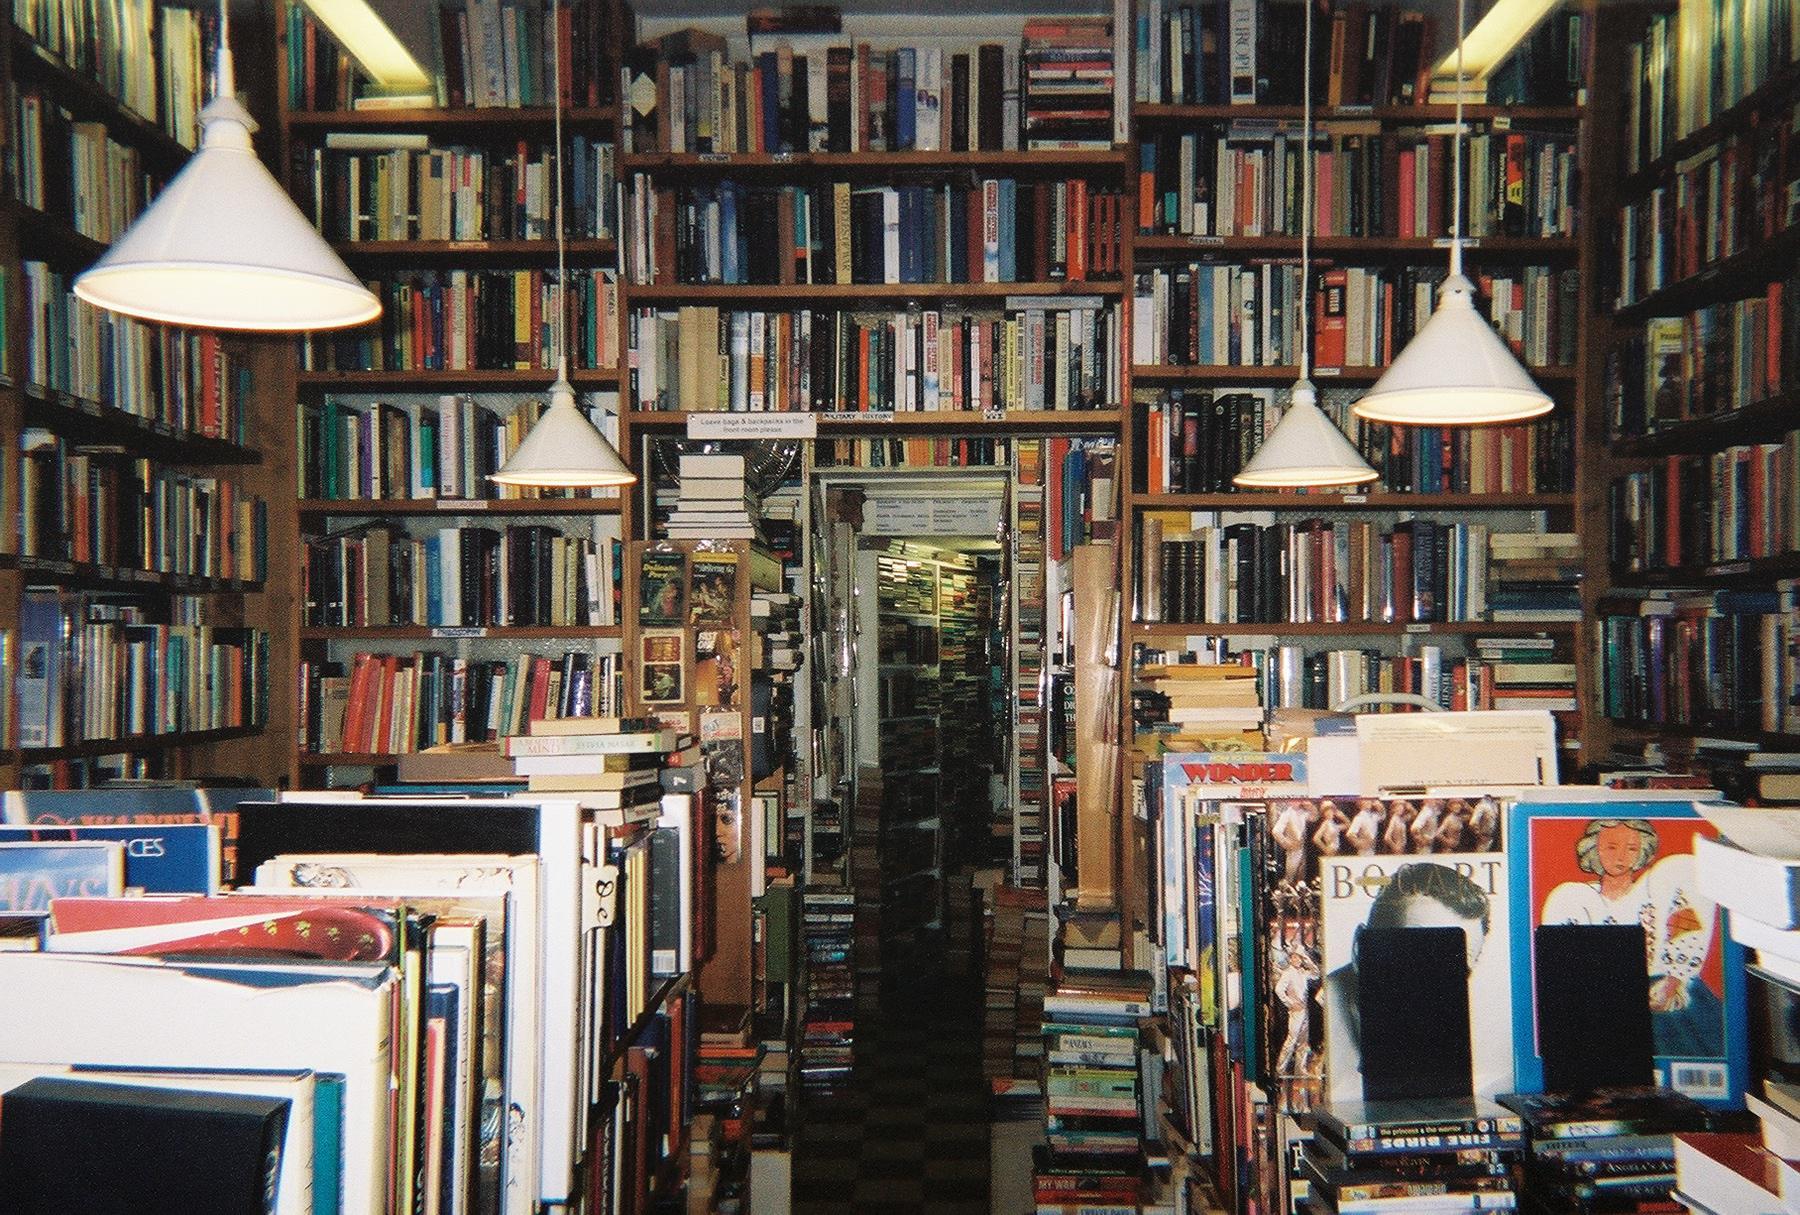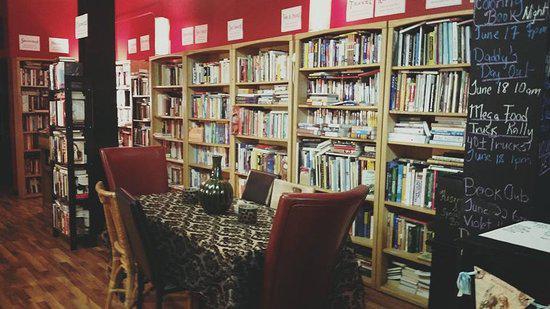The first image is the image on the left, the second image is the image on the right. Assess this claim about the two images: "There are multiple people in a bookstore in the left image.". Correct or not? Answer yes or no. No. 